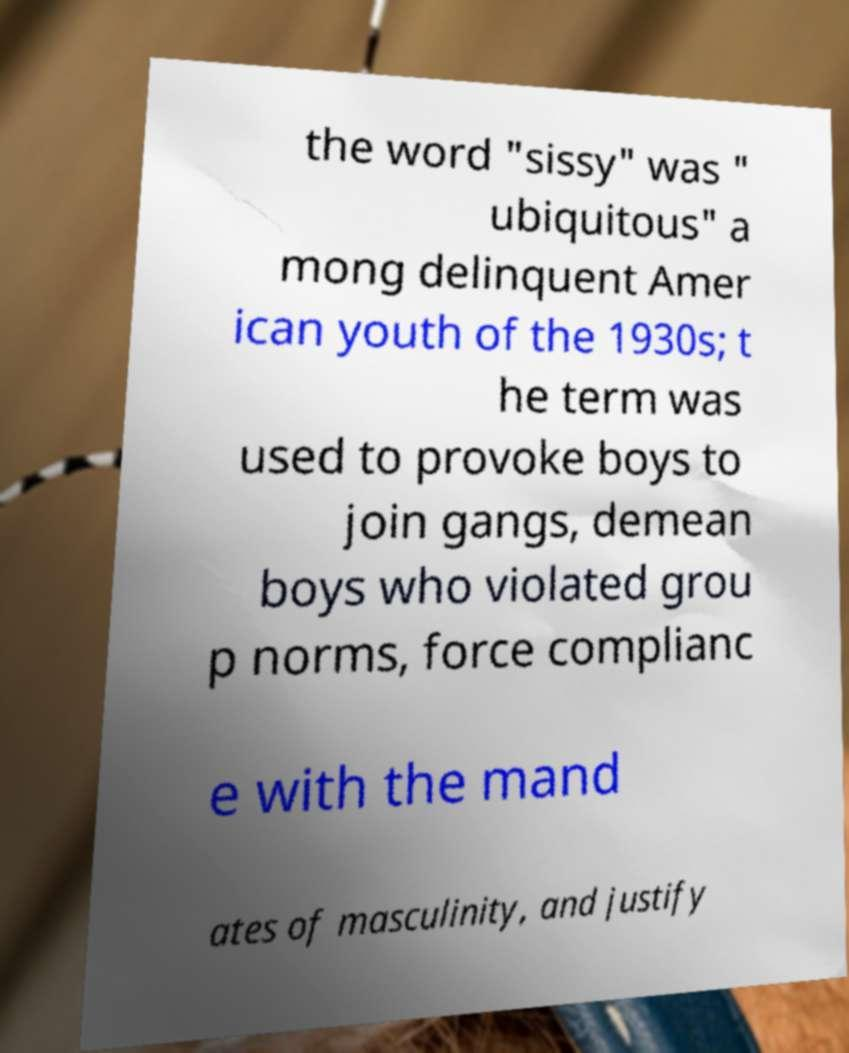Can you read and provide the text displayed in the image?This photo seems to have some interesting text. Can you extract and type it out for me? the word "sissy" was " ubiquitous" a mong delinquent Amer ican youth of the 1930s; t he term was used to provoke boys to join gangs, demean boys who violated grou p norms, force complianc e with the mand ates of masculinity, and justify 